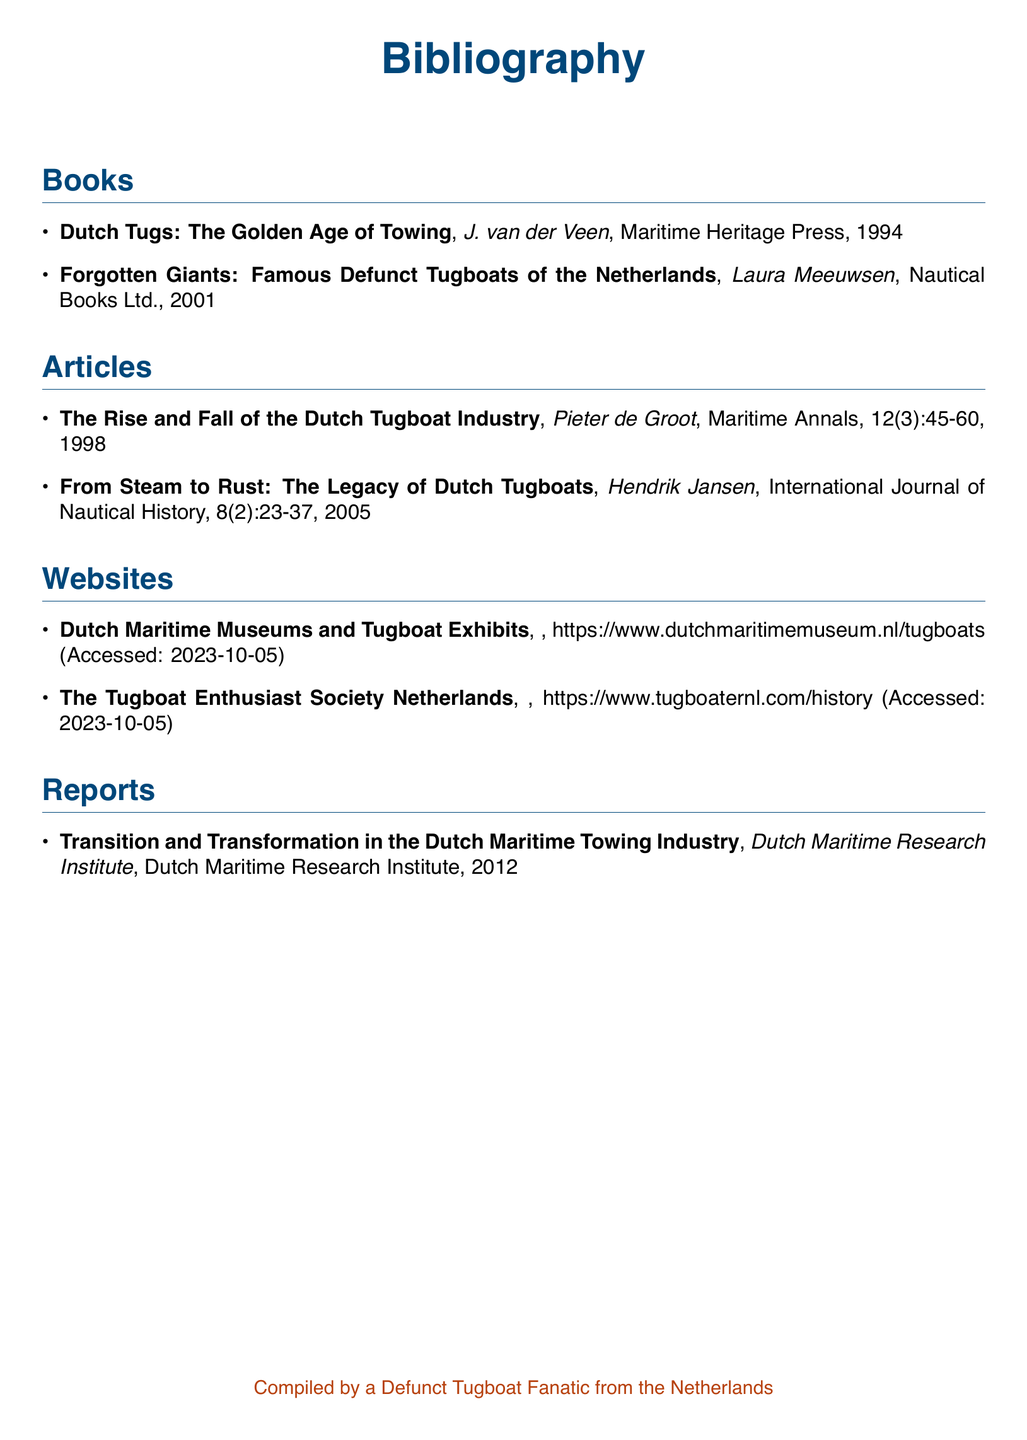what is the title of the first book listed? The title of the first book listed is the first entry in the Books section of the bibliography.
Answer: Dutch Tugs: The Golden Age of Towing who authored "Forgotten Giants: Famous Defunct Tugboats of the Netherlands"? The author of this book is mentioned directly in the corresponding entry of the Books section.
Answer: Laura Meeuwsen what is the publication year of the article titled "The Rise and Fall of the Dutch Tugboat Industry"? The publication year can be found in the citation details of the specific article in the Articles section.
Answer: 1998 how many websites are referenced in this bibliography? The total number of websites can be counted from the Websites section of the document.
Answer: 2 who compiled this bibliography? The compiler's name is mentioned at the bottom of the document.
Answer: A Defunct Tugboat Fanatic from the Netherlands what institute published the report on the Dutch maritime towing industry? The name of the institute is found in the entry under the Reports section.
Answer: Dutch Maritime Research Institute what is the color of the title section in this document? The color of the title section is defined in the document and applied to the title format.
Answer: Tugboat blue in which journal was the article "From Steam to Rust: The Legacy of Dutch Tugboats" published? This information can be found in the citation details of the article in the Articles section.
Answer: International Journal of Nautical History 